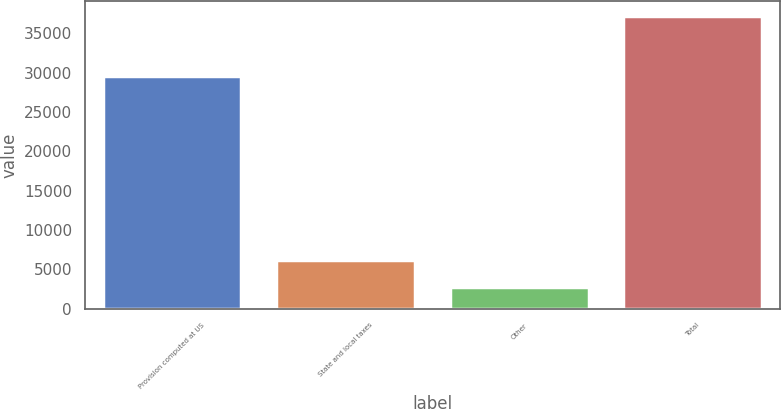Convert chart. <chart><loc_0><loc_0><loc_500><loc_500><bar_chart><fcel>Provision computed at US<fcel>State and local taxes<fcel>Other<fcel>Total<nl><fcel>29623<fcel>6208.8<fcel>2761<fcel>37239<nl></chart> 